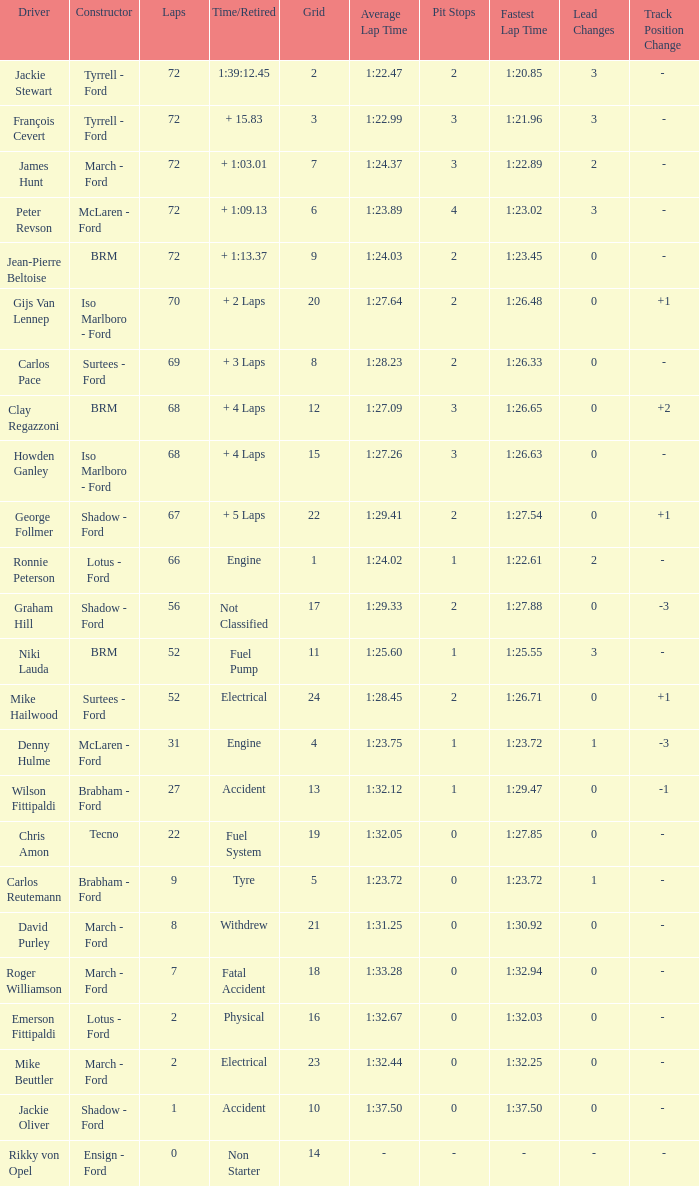What is the top grid that roger williamson lapped less than 7? None. 